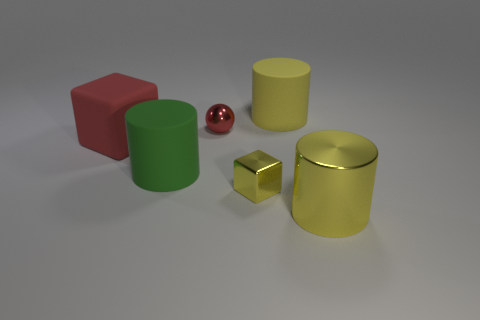What textures do the objects in the image have? In the image, we have a variety of textures. The red cube and green cylinder feature a matte, non-reflective surface. The yellow objects, both the cylinder and the cube, appear to have a reflective, metallic finish, whereas the red sphere has a glossy, reflective texture. 